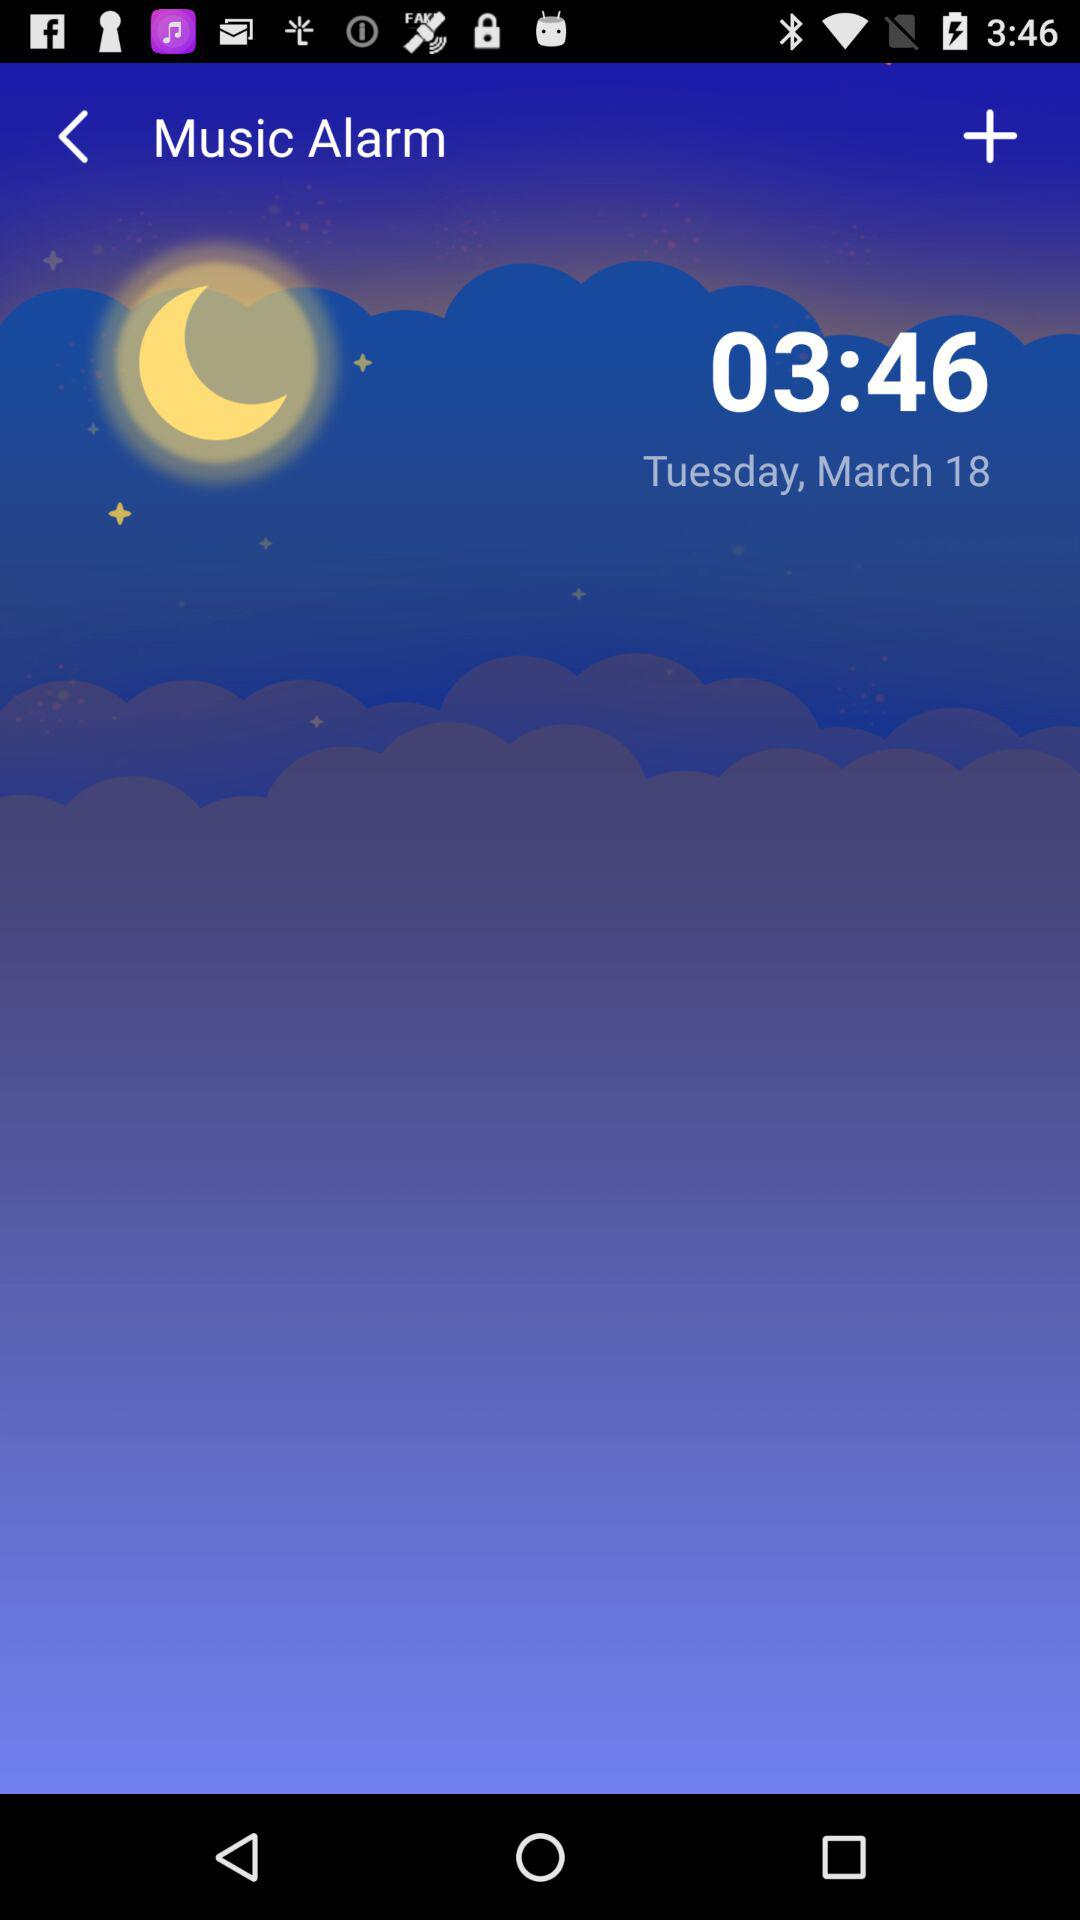What is the time? The time is 03:46. 